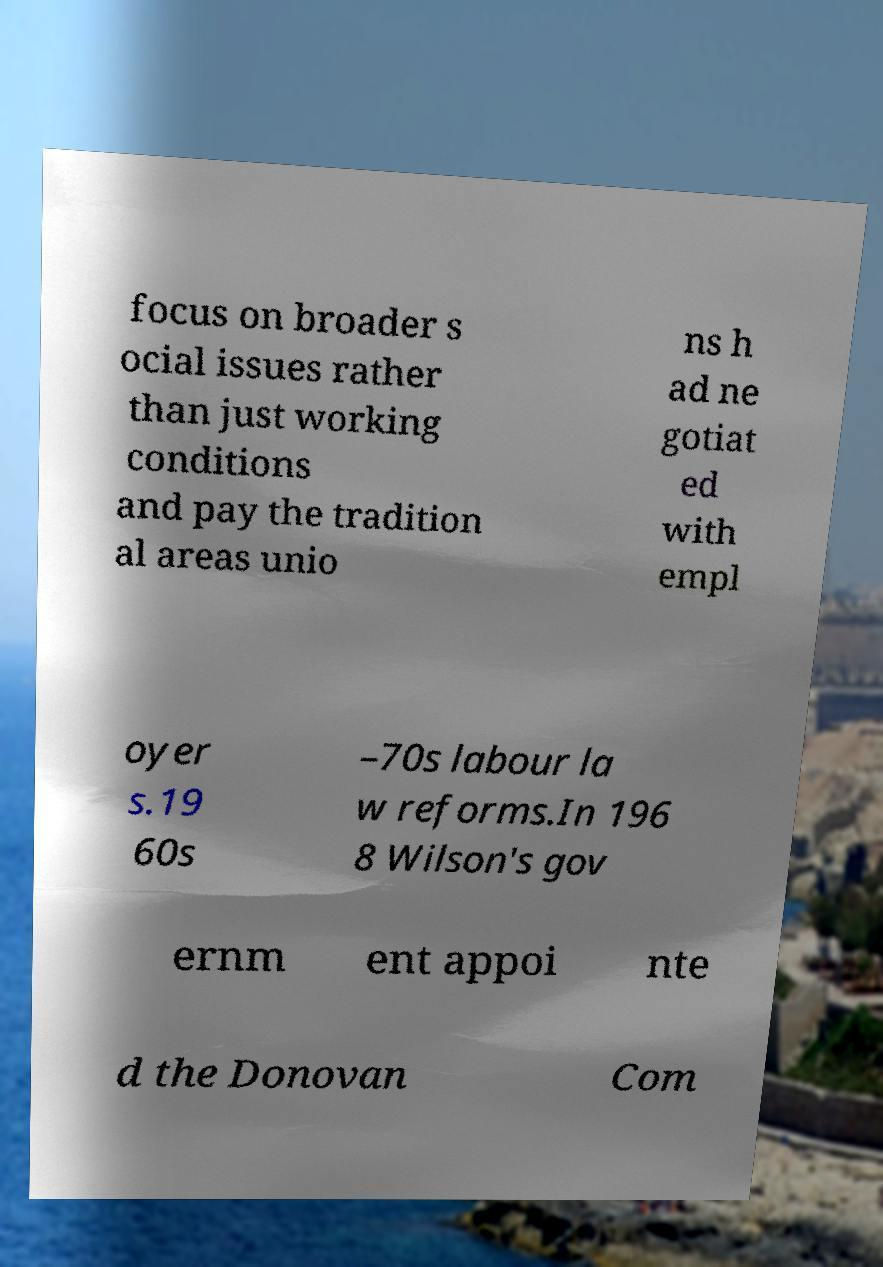What messages or text are displayed in this image? I need them in a readable, typed format. focus on broader s ocial issues rather than just working conditions and pay the tradition al areas unio ns h ad ne gotiat ed with empl oyer s.19 60s –70s labour la w reforms.In 196 8 Wilson's gov ernm ent appoi nte d the Donovan Com 